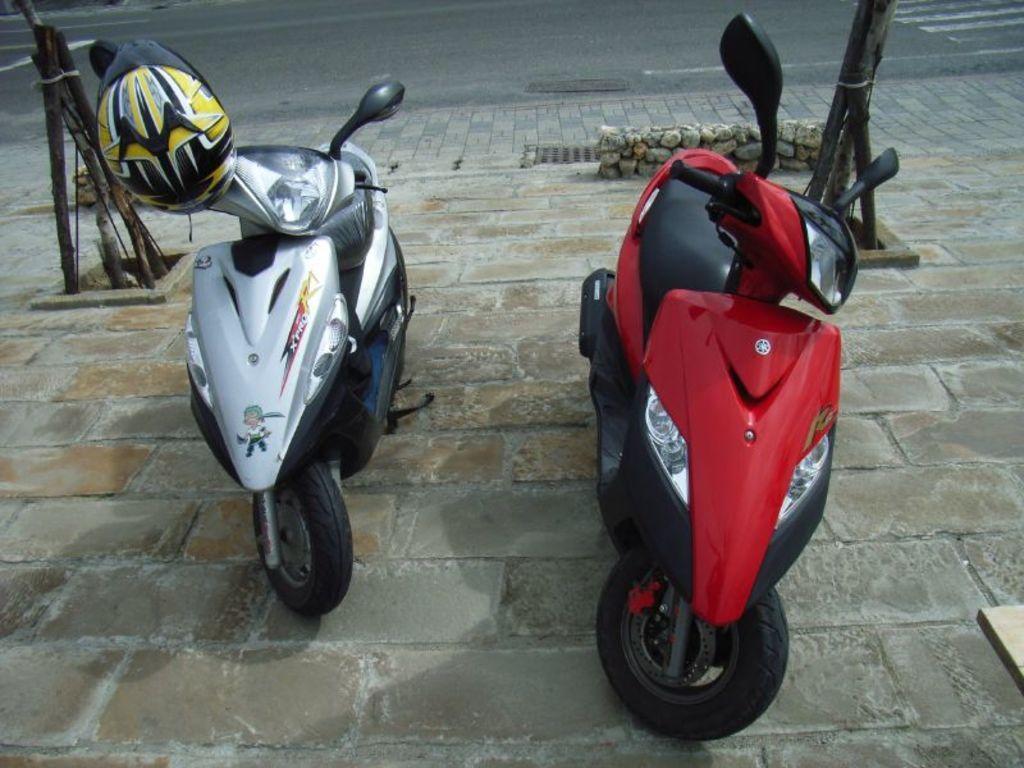Could you give a brief overview of what you see in this image? In the image there are two scooters on the side of the road with a helmet on the left side bike and behind there is road. 